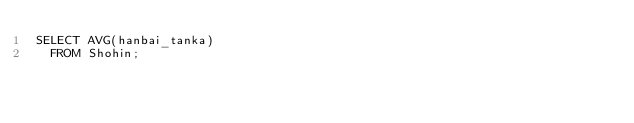Convert code to text. <code><loc_0><loc_0><loc_500><loc_500><_SQL_>SELECT AVG(hanbai_tanka)
  FROM Shohin;</code> 